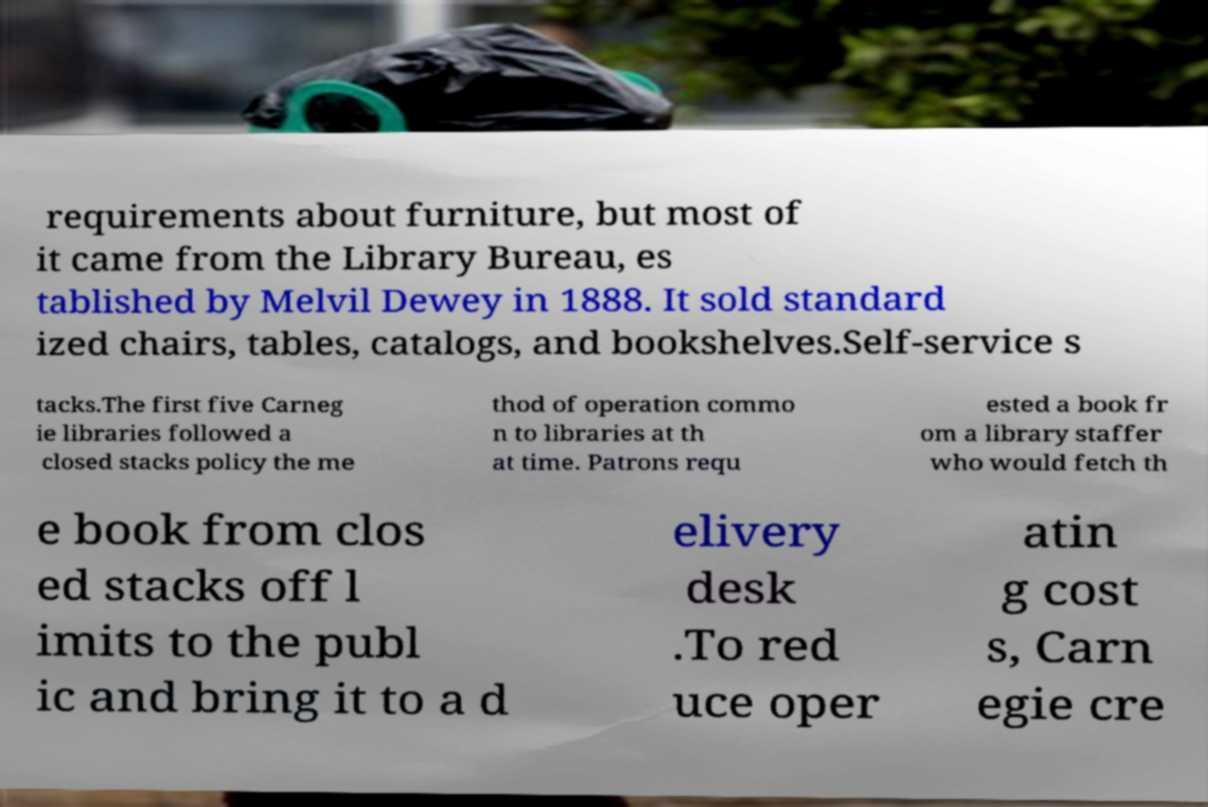Please read and relay the text visible in this image. What does it say? requirements about furniture, but most of it came from the Library Bureau, es tablished by Melvil Dewey in 1888. It sold standard ized chairs, tables, catalogs, and bookshelves.Self-service s tacks.The first five Carneg ie libraries followed a closed stacks policy the me thod of operation commo n to libraries at th at time. Patrons requ ested a book fr om a library staffer who would fetch th e book from clos ed stacks off l imits to the publ ic and bring it to a d elivery desk .To red uce oper atin g cost s, Carn egie cre 